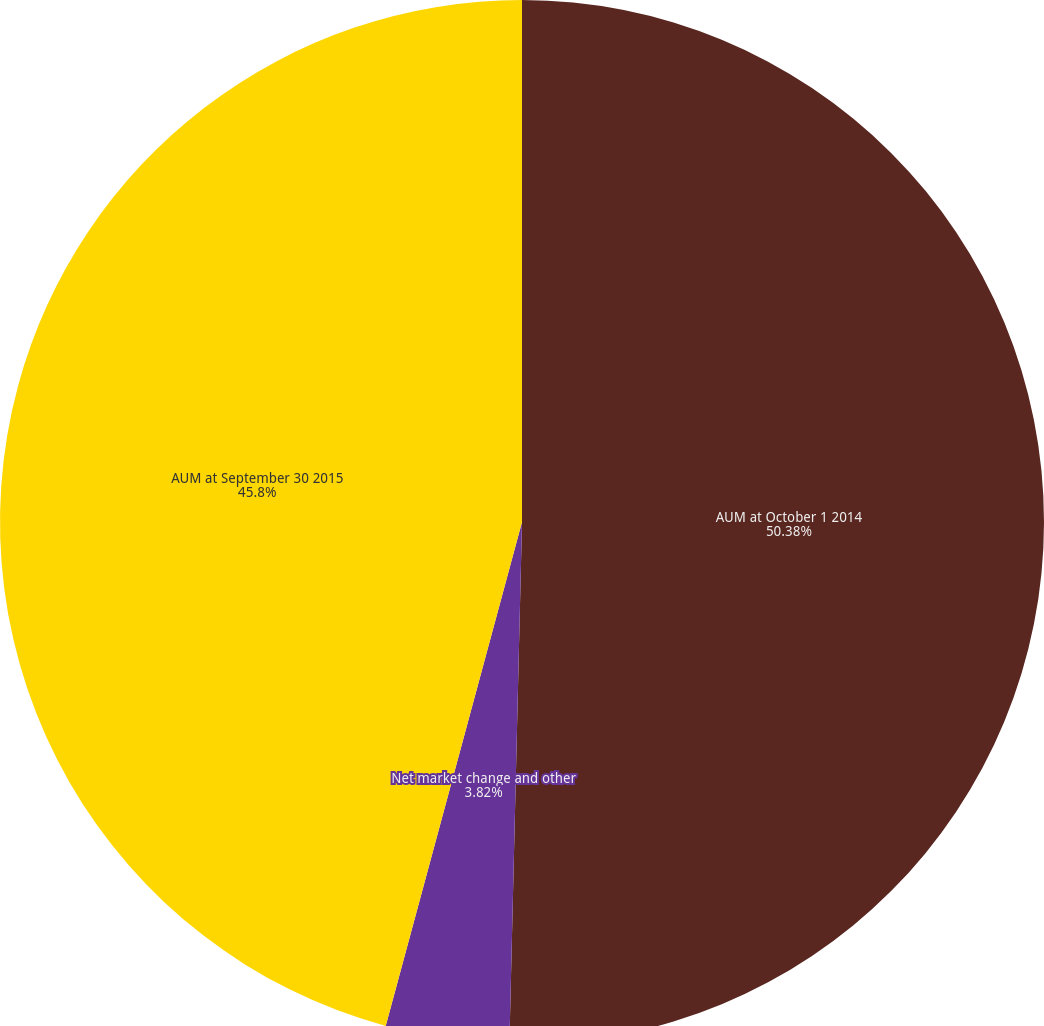Convert chart to OTSL. <chart><loc_0><loc_0><loc_500><loc_500><pie_chart><fcel>AUM at October 1 2014<fcel>Net market change and other<fcel>AUM at September 30 2015<nl><fcel>50.39%<fcel>3.82%<fcel>45.8%<nl></chart> 